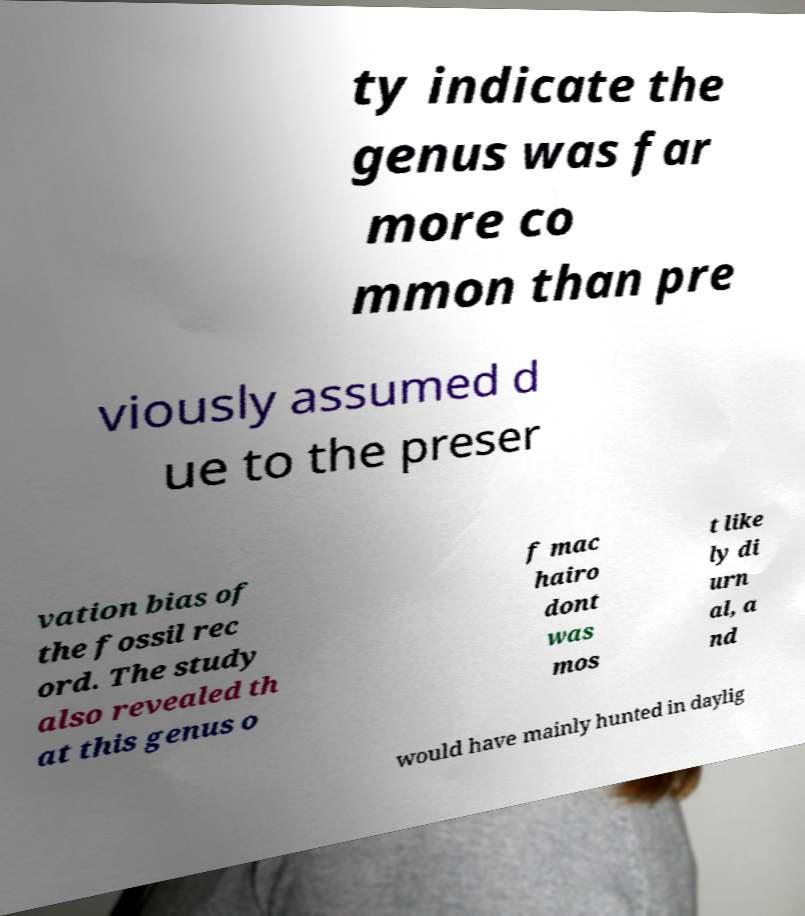I need the written content from this picture converted into text. Can you do that? ty indicate the genus was far more co mmon than pre viously assumed d ue to the preser vation bias of the fossil rec ord. The study also revealed th at this genus o f mac hairo dont was mos t like ly di urn al, a nd would have mainly hunted in daylig 